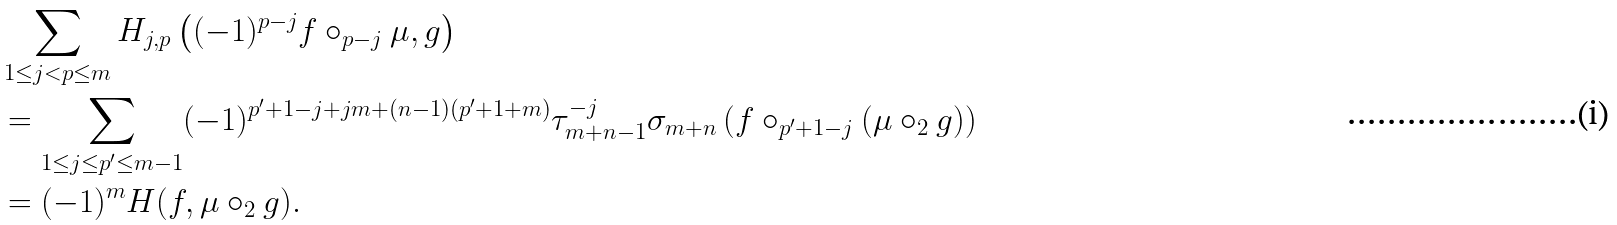Convert formula to latex. <formula><loc_0><loc_0><loc_500><loc_500>& \sum _ { 1 \leq j < p \leq m } H _ { j , p } \left ( ( - 1 ) ^ { p - j } f \circ _ { p - j } \mu , g \right ) \\ & = \sum _ { 1 \leq j \leq p ^ { \prime } \leq m - 1 } ( - 1 ) ^ { p ^ { \prime } + 1 - j + j m + ( n - 1 ) ( p ^ { \prime } + 1 + m ) } \tau ^ { - j } _ { m + n - 1 } \sigma _ { m + n } \left ( f \circ _ { p ^ { \prime } + 1 - j } ( \mu \circ _ { 2 } g ) \right ) \\ & = ( - 1 ) ^ { m } H ( f , \mu \circ _ { 2 } g ) .</formula> 